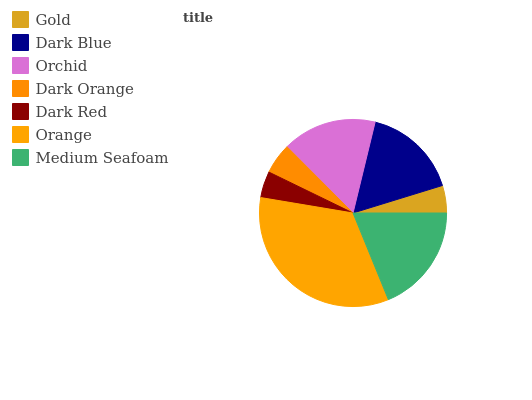Is Dark Red the minimum?
Answer yes or no. Yes. Is Orange the maximum?
Answer yes or no. Yes. Is Dark Blue the minimum?
Answer yes or no. No. Is Dark Blue the maximum?
Answer yes or no. No. Is Dark Blue greater than Gold?
Answer yes or no. Yes. Is Gold less than Dark Blue?
Answer yes or no. Yes. Is Gold greater than Dark Blue?
Answer yes or no. No. Is Dark Blue less than Gold?
Answer yes or no. No. Is Orchid the high median?
Answer yes or no. Yes. Is Orchid the low median?
Answer yes or no. Yes. Is Medium Seafoam the high median?
Answer yes or no. No. Is Gold the low median?
Answer yes or no. No. 